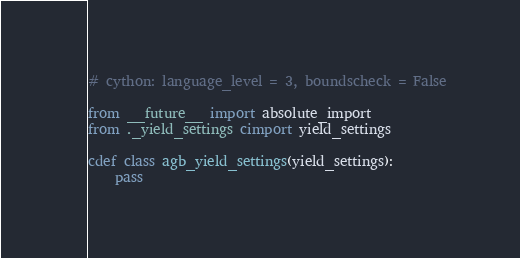Convert code to text. <code><loc_0><loc_0><loc_500><loc_500><_Cython_># cython: language_level = 3, boundscheck = False

from __future__ import absolute_import 
from ._yield_settings cimport yield_settings 

cdef class agb_yield_settings(yield_settings): 
	pass 


</code> 